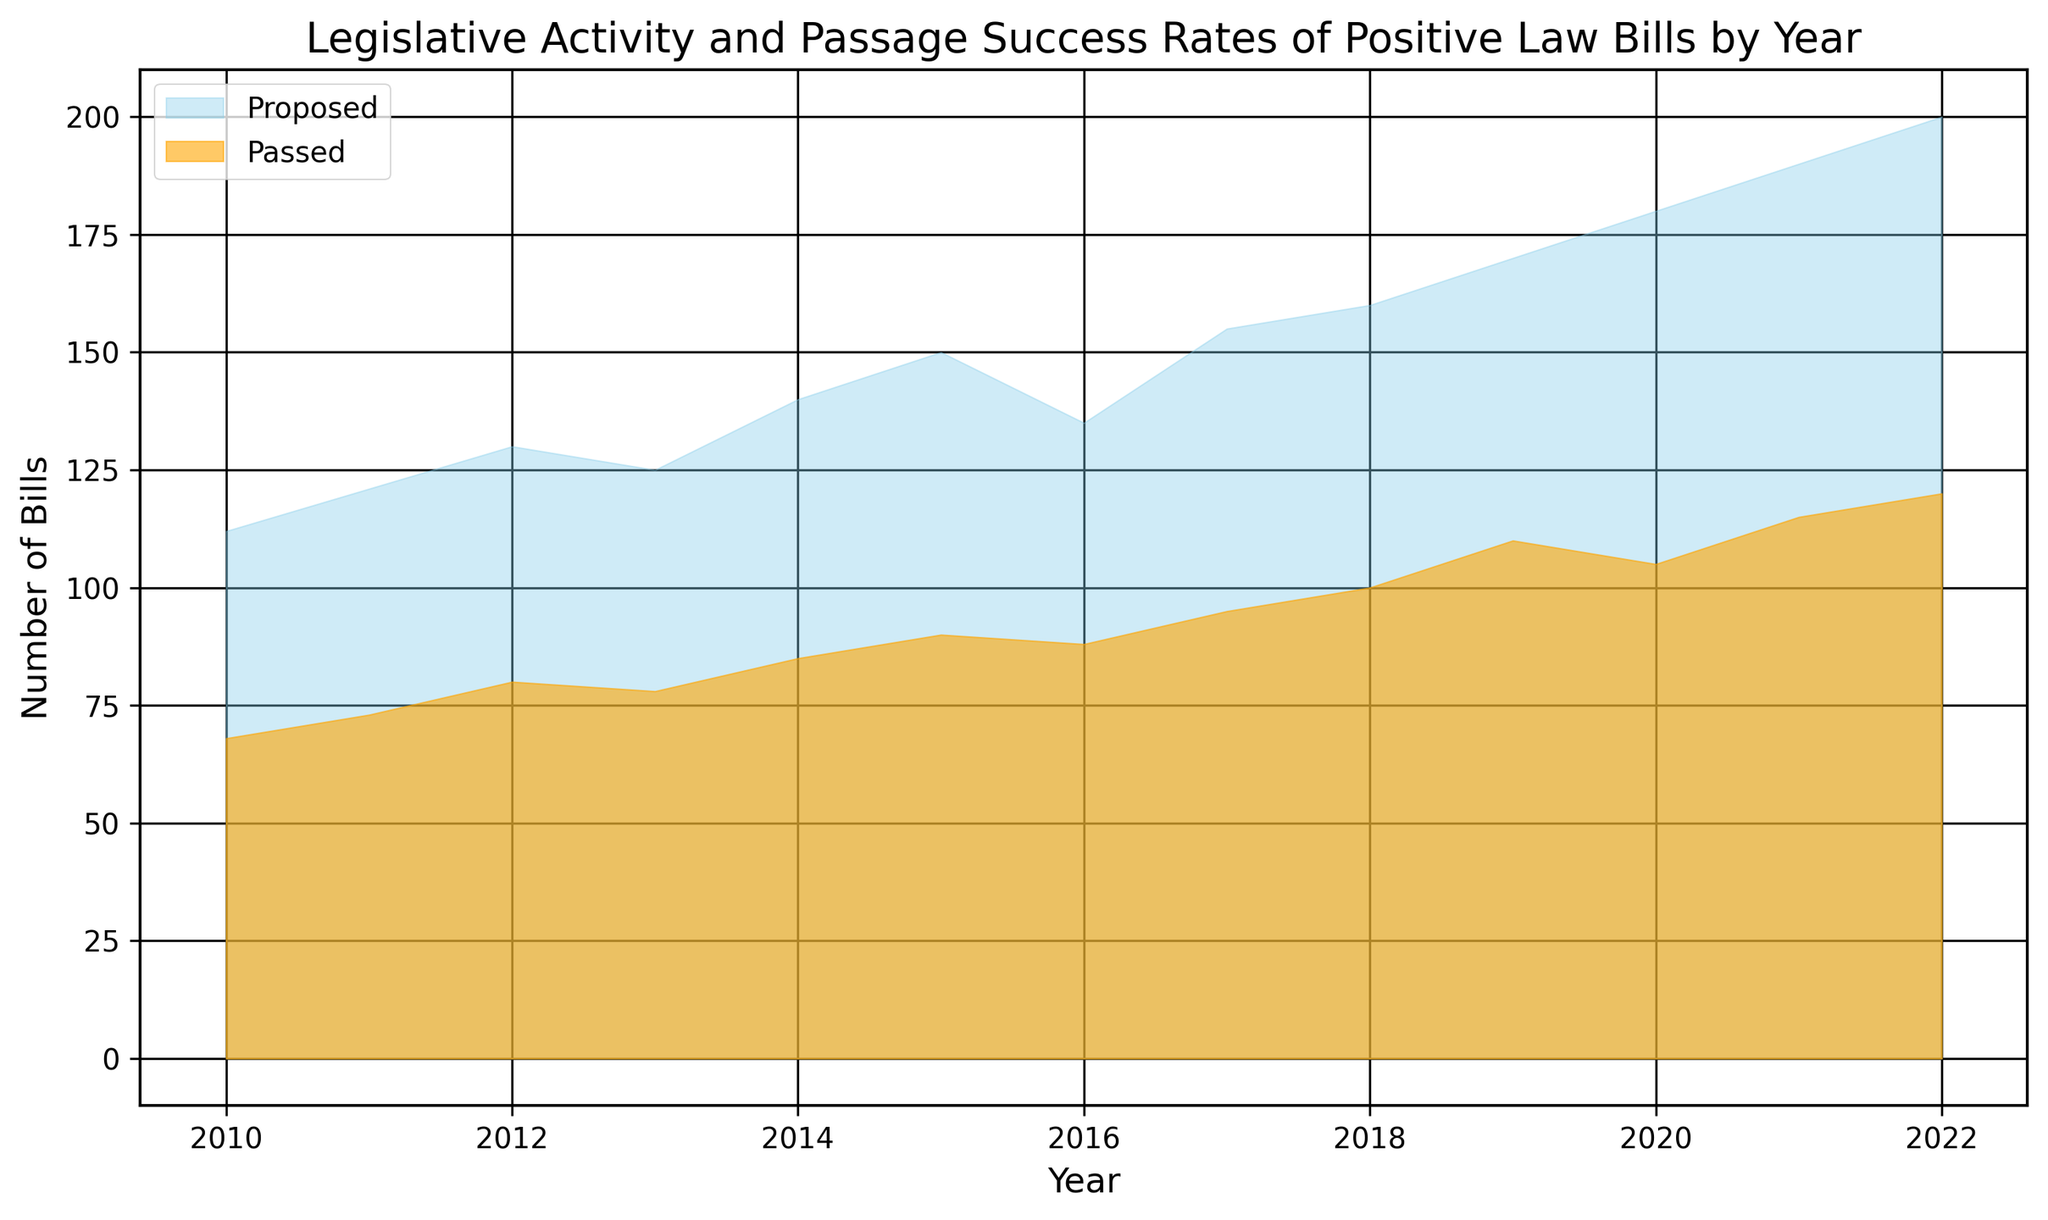What is the trend in the number of Positive Law Bills Proposed from 2010 to 2022? To determine the trend, look at the general direction of the area representing "Positive Law Bills Proposed." It starts at 112 in 2010 and increases every year until reaching 200 in 2022.
Answer: Increasing In which year was the gap between Positive Law Bills Proposed and Passed the smallest? To find the smallest gap, calculate the difference between proposed and passed bills for each year. The smallest difference is 60, occurring in 2022.
Answer: 2022 How many more Positive Law Bills were Passed in 2018 than in 2010? Look at the number of Positive Law Bills Passed in 2018 (100) and 2010 (68), then subtract the 2010 figure from the 2018 figure: 100 - 68 = 32.
Answer: 32 Which color represents Positive Law Bills Passed, and what visual attribute distinguishes it in the chart? The color representing Positive Law Bills Passed is orange, and it is distinguished by its slightly more opaque appearance compared to the sky-blue color for Proposed bills.
Answer: Orange and more opaque In which year did the number of Positive Law Bills Passed first exceed 100? Identify the year where the number of Positive Law Bills Passed first crosses 100. In 2018, this value reaches exactly 100 for the first time.
Answer: 2018 What is the average number of Positive Law Bills Proposed from 2010 to 2022? Sum the number of Positive Law Bills Proposed from 2010 to 2022, then divide by the total number of years (13). The sum is 1968, so the average is 1968 / 13 ≈ 151.4.
Answer: 151.4 Compare the growth rate in Positive Law Bills Proposed between the periods 2010-2015 and 2016-2022. Calculate the growth in each period: from 112 in 2010 to 150 in 2015, the growth is 38. From 135 in 2016 to 200 in 2022, the growth is 65. Compare these growth amounts across the two periods.
Answer: Faster in 2016-2022 Which year saw the highest number of Positive Law Bills Passed, and what is that number? The highest number of Positive Law Bills Passed can be found at the peak of the orange area, occurring in 2022 with 120 bills.
Answer: 2022, 120 What was the rate of increase in Positive Law Bills Proposed from 2010 to 2022? To calculate the rate of increase, consider the initial and final values: 112 in 2010 and 200 in 2022. The rate is (200 - 112) / 112 ≈ 0.7857 or 78.57%.
Answer: 78.57% If we assume the trend continues, how many Positive Law Bills might be passed in 2023, given the previous trend? Observing the increase in Positive Law Bills Passed year over year, there is an approximate addition of 5-10 bills each year recently. Thus, if the trend continues, the number in 2023 might be about 125-130.
Answer: 125-130 